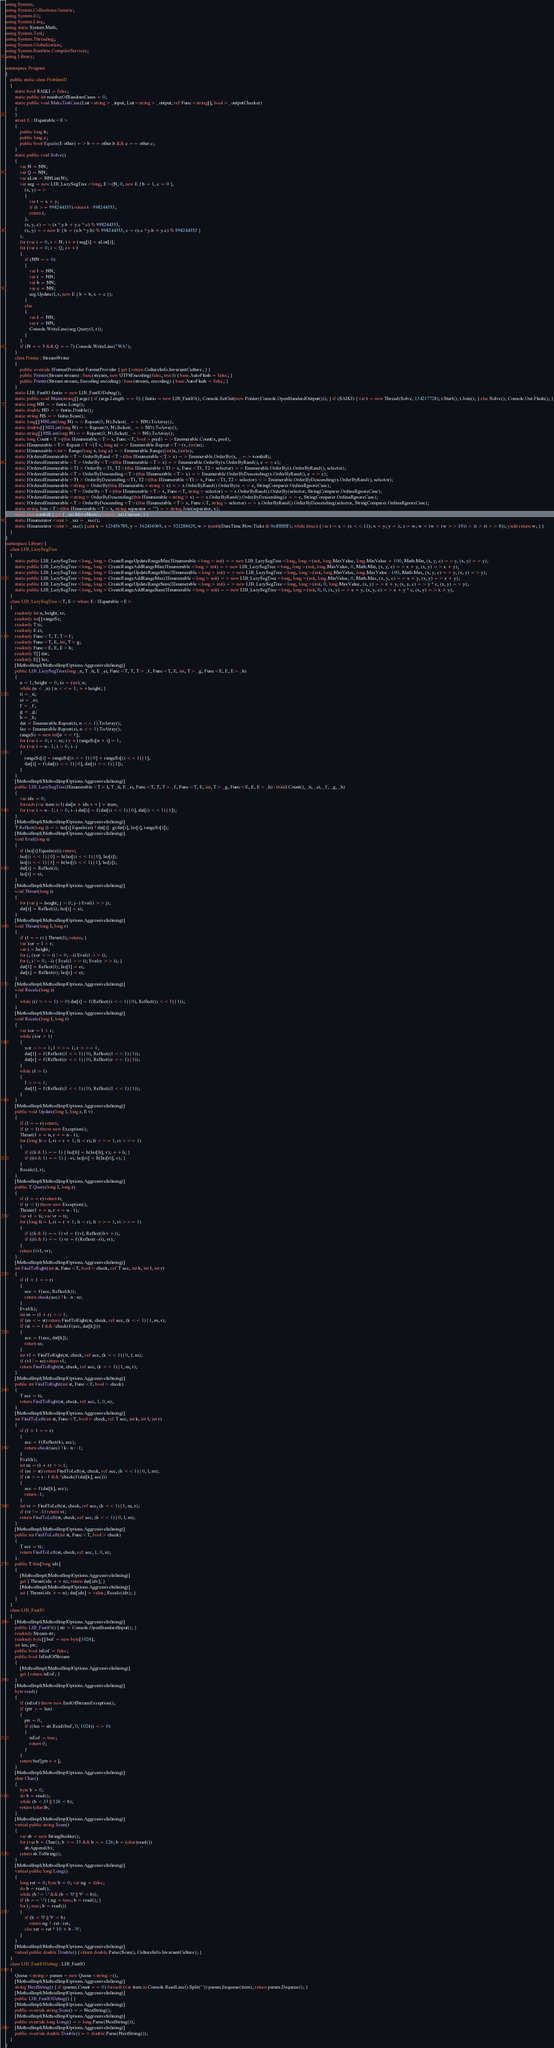Convert code to text. <code><loc_0><loc_0><loc_500><loc_500><_C#_>using System;
using System.Collections.Generic;
using System.IO;
using System.Linq;
using static System.Math;
using System.Text;
using System.Threading;
using System.Globalization;
using System.Runtime.CompilerServices;
using Library;

namespace Program
{
    public static class ProblemD
    {
        static bool SAIKI = false;
        static public int numberOfRandomCases = 0;
        static public void MakeTestCase(List<string> _input, List<string> _output, ref Func<string[], bool> _outputChecker)
        {
        }
        struct E : IEquatable<E>
        {
            public long b;
            public long c;
            public bool Equals(E other) => b == other.b && c == other.c;
        }
        static public void Solve()
        {
            var N = NN;
            var Q = NN;
            var aList = NNList(N);
            var seg = new LIB_LazySegTree<long, E>(N, 0, new E { b = 1, c = 0 },
                (x, y) =>
                {
                    var t = x + y;
                    if (t >= 998244353) return t - 998244353;
                    return t;
                },
                (x, y, c) => (x * y.b + y.c * c) % 998244353,
                (x, y) => new E { b = (x.b * y.b) % 998244353, c = (x.c * y.b + y.c) % 998244353 }
            );
            for (var i = 0; i < N; i++) seg[i] = aList[i];
            for (var i = 0; i < Q; i++)
            {
                if (NN == 0)
                {
                    var l = NN;
                    var r = NN;
                    var b = NN;
                    var c = NN;
                    seg.Update(l, r, new E { b = b, c = c });
                }
                else
                {
                    var l = NN;
                    var r = NN;
                    Console.WriteLine(seg.Query(l, r));
                }
            }
            if (N == 5 && Q == 7) Console.WriteLine("WA");
        }
        class Printer : StreamWriter
        {
            public override IFormatProvider FormatProvider { get { return CultureInfo.InvariantCulture; } }
            public Printer(Stream stream) : base(stream, new UTF8Encoding(false, true)) { base.AutoFlush = false; }
            public Printer(Stream stream, Encoding encoding) : base(stream, encoding) { base.AutoFlush = false; }
        }
        static LIB_FastIO fastio = new LIB_FastIODebug();
        static public void Main(string[] args) { if (args.Length == 0) { fastio = new LIB_FastIO(); Console.SetOut(new Printer(Console.OpenStandardOutput())); } if (SAIKI) { var t = new Thread(Solve, 134217728); t.Start(); t.Join(); } else Solve(); Console.Out.Flush(); }
        static long NN => fastio.Long();
        static double ND => fastio.Double();
        static string NS => fastio.Scan();
        static long[] NNList(long N) => Repeat(0, N).Select(_ => NN).ToArray();
        static double[] NDList(long N) => Repeat(0, N).Select(_ => ND).ToArray();
        static string[] NSList(long N) => Repeat(0, N).Select(_ => NS).ToArray();
        static long Count<T>(this IEnumerable<T> x, Func<T, bool> pred) => Enumerable.Count(x, pred);
        static IEnumerable<T> Repeat<T>(T v, long n) => Enumerable.Repeat<T>(v, (int)n);
        static IEnumerable<int> Range(long s, long c) => Enumerable.Range((int)s, (int)c);
        static IOrderedEnumerable<T> OrderByRand<T>(this IEnumerable<T> x) => Enumerable.OrderBy(x, _ => xorshift);
        static IOrderedEnumerable<T> OrderBy<T>(this IEnumerable<T> x) => Enumerable.OrderBy(x.OrderByRand(), e => e);
        static IOrderedEnumerable<T1> OrderBy<T1, T2>(this IEnumerable<T1> x, Func<T1, T2> selector) => Enumerable.OrderBy(x.OrderByRand(), selector);
        static IOrderedEnumerable<T> OrderByDescending<T>(this IEnumerable<T> x) => Enumerable.OrderByDescending(x.OrderByRand(), e => e);
        static IOrderedEnumerable<T1> OrderByDescending<T1, T2>(this IEnumerable<T1> x, Func<T1, T2> selector) => Enumerable.OrderByDescending(x.OrderByRand(), selector);
        static IOrderedEnumerable<string> OrderBy(this IEnumerable<string> x) => x.OrderByRand().OrderBy(e => e, StringComparer.OrdinalIgnoreCase);
        static IOrderedEnumerable<T> OrderBy<T>(this IEnumerable<T> x, Func<T, string> selector) => x.OrderByRand().OrderBy(selector, StringComparer.OrdinalIgnoreCase);
        static IOrderedEnumerable<string> OrderByDescending(this IEnumerable<string> x) => x.OrderByRand().OrderByDescending(e => e, StringComparer.OrdinalIgnoreCase);
        static IOrderedEnumerable<T> OrderByDescending<T>(this IEnumerable<T> x, Func<T, string> selector) => x.OrderByRand().OrderByDescending(selector, StringComparer.OrdinalIgnoreCase);
        static string Join<T>(this IEnumerable<T> x, string separator = "") => string.Join(separator, x);
        static uint xorshift { get { _xsi.MoveNext(); return _xsi.Current; } }
        static IEnumerator<uint> _xsi = _xsc();
        static IEnumerator<uint> _xsc() { uint x = 123456789, y = 362436069, z = 521288629, w = (uint)(DateTime.Now.Ticks & 0xffffffff); while (true) { var t = x ^ (x << 11); x = y; y = z; z = w; w = (w ^ (w >> 19)) ^ (t ^ (t >> 8)); yield return w; } }
    }
}
namespace Library {
    class LIB_LazySegTree
    {
        static public LIB_LazySegTree<long, long> CreateRangeUpdateRangeMin(IEnumerable<long> init) => new LIB_LazySegTree<long, long>(init, long.MaxValue, long.MinValue + 100, Math.Min, (x, y, c) => y, (x, y) => y);
        static public LIB_LazySegTree<long, long> CreateRangeAddRangeMin(IEnumerable<long> init) => new LIB_LazySegTree<long, long>(init, long.MaxValue, 0, Math.Min, (x, y, c) => x + y, (x, y) => x + y);
        static public LIB_LazySegTree<long, long> CreateRangeUpdateRangeMax(IEnumerable<long> init) => new LIB_LazySegTree<long, long>(init, long.MinValue, long.MaxValue - 100, Math.Max, (x, y, c) => y, (x, y) => y);
        static public LIB_LazySegTree<long, long> CreateRangeAddRangeMax(IEnumerable<long> init) => new LIB_LazySegTree<long, long>(init, long.MinValue, 0, Math.Max, (x, y, c) => x + y, (x, y) => x + y);
        static public LIB_LazySegTree<long, long> CreateRangeUpdateRangeSum(IEnumerable<long> init) => new LIB_LazySegTree<long, long>(init, 0, long.MaxValue, (x, y) => x + y, (x, y, c) => y * c, (x, y) => y);
        static public LIB_LazySegTree<long, long> CreateRangeAddRangeSum(IEnumerable<long> init) => new LIB_LazySegTree<long, long>(init, 0, 0, (x, y) => x + y, (x, y, c) => x + y * c, (x, y) => x + y);
    }
    class LIB_LazySegTree<T, E> where E : IEquatable<E>
    {
        readonly int n, height, sz;
        readonly int[] rangeSz;
        readonly T ti;
        readonly E ei;
        readonly Func<T, T, T> f;
        readonly Func<T, E, int, T> g;
        readonly Func<E, E, E> h;
        readonly T[] dat;
        readonly E[] laz;
        [MethodImpl(MethodImplOptions.AggressiveInlining)]
        public LIB_LazySegTree(long _n, T _ti, E _ei, Func<T, T, T> _f, Func<T, E, int, T> _g, Func<E, E, E> _h)
        {
            n = 1; height = 0; sz = (int)_n;
            while (n < _n) { n <<= 1; ++height; }
            ti = _ti;
            ei = _ei;
            f = _f;
            g = _g;
            h = _h;
            dat = Enumerable.Repeat(ti, n << 1).ToArray();
            laz = Enumerable.Repeat(ei, n << 1).ToArray();
            rangeSz = new int[n << 1];
            for (var i = 0; i < sz; i++) rangeSz[n + i] = 1;
            for (var i = n - 1; i > 0; i--)
            {
                rangeSz[i] = rangeSz[(i << 1) | 0] + rangeSz[(i << 1) | 1];
                dat[i] = f(dat[(i << 1) | 0], dat[(i << 1) | 1]);
            }
        }
        [MethodImpl(MethodImplOptions.AggressiveInlining)]
        public LIB_LazySegTree(IEnumerable<T> l, T _ti, E _ei, Func<T, T, T> _f, Func<T, E, int, T> _g, Func<E, E, E> _h) : this(l.Count(), _ti, _ei, _f, _g, _h)
        {
            var idx = 0;
            foreach (var item in l) dat[n + idx++] = item;
            for (var i = n - 1; i > 0; i--) dat[i] = f(dat[(i << 1) | 0], dat[(i << 1) | 1]);
        }
        [MethodImpl(MethodImplOptions.AggressiveInlining)]
        T Reflect(long i) => laz[i].Equals(ei) ? dat[i] : g(dat[i], laz[i], rangeSz[i]);
        [MethodImpl(MethodImplOptions.AggressiveInlining)]
        void Eval(long i)
        {
            if (laz[i].Equals(ei)) return;
            laz[(i << 1) | 0] = h(laz[(i << 1) | 0], laz[i]);
            laz[(i << 1) | 1] = h(laz[(i << 1) | 1], laz[i]);
            dat[i] = Reflect(i);
            laz[i] = ei;
        }
        [MethodImpl(MethodImplOptions.AggressiveInlining)]
        void Thrust(long i)
        {
            for (var j = height; j > 0; j--) Eval(i >> j);
            dat[i] = Reflect(i); laz[i] = ei;
        }
        [MethodImpl(MethodImplOptions.AggressiveInlining)]
        void Thrust(long l, long r)
        {
            if (l == r) { Thrust(l); return; }
            var xor = l ^ r;
            var i = height;
            for (; (xor >> i) != 0; --i) Eval(l >> i);
            for (; i != 0; --i) { Eval(l >> i); Eval(r >> i); }
            dat[l] = Reflect(l); laz[l] = ei;
            dat[r] = Reflect(r); laz[r] = ei;
        }
        [MethodImpl(MethodImplOptions.AggressiveInlining)]
        void Recalc(long i)
        {
            while ((i >>= 1) > 0) dat[i] = f(Reflect((i << 1) | 0), Reflect((i << 1) | 1));
        }
        [MethodImpl(MethodImplOptions.AggressiveInlining)]
        void Recalc(long l, long r)
        {
            var xor = l ^ r;
            while (xor > 1)
            {
                xor >>= 1; l >>= 1; r >>= 1;
                dat[l] = f(Reflect((l << 1) | 0), Reflect((l << 1) | 1));
                dat[r] = f(Reflect((r << 1) | 0), Reflect((r << 1) | 1));
            }
            while (l > 1)
            {
                l >>= 1;
                dat[l] = f(Reflect((l << 1) | 0), Reflect((l << 1) | 1));
            }
        }
        [MethodImpl(MethodImplOptions.AggressiveInlining)]
        public void Update(long l, long r, E v)
        {
            if (l == r) return;
            if (r < l) throw new Exception();
            Thrust(l += n, r += n - 1);
            for (long li = l, ri = r + 1; li < ri; li >>= 1, ri >>= 1)
            {
                if ((li & 1) == 1) { laz[li] = h(laz[li], v); ++li; }
                if ((ri & 1) == 1) { --ri; laz[ri] = h(laz[ri], v); }
            }
            Recalc(l, r);
        }
        [MethodImpl(MethodImplOptions.AggressiveInlining)]
        public T Query(long l, long r)
        {
            if (l == r) return ti;
            if (r < l) throw new Exception();
            Thrust(l += n, r += n - 1);
            var vl = ti; var vr = ti;
            for (long li = l, ri = r + 1; li < ri; li >>= 1, ri >>= 1)
            {
                if ((li & 1) == 1) vl = f(vl, Reflect(li++));
                if ((ri & 1) == 1) vr = f(Reflect(--ri), vr);
            }
            return f(vl, vr);
        }
        [MethodImpl(MethodImplOptions.AggressiveInlining)]
        int FindToRight(int st, Func<T, bool> check, ref T acc, int k, int l, int r)
        {
            if (l + 1 == r)
            {
                acc = f(acc, Reflect(k));
                return check(acc) ? k - n : sz;
            }
            Eval(k);
            int m = (l + r) >> 1;
            if (m <= st) return FindToRight(st, check, ref acc, (k << 1) | 1, m, r);
            if (st <= l && !check(f(acc, dat[k])))
            {
                acc = f(acc, dat[k]);
                return sz;
            }
            int vl = FindToRight(st, check, ref acc, (k << 1) | 0, l, m);
            if (vl != sz) return vl;
            return FindToRight(st, check, ref acc, (k << 1) | 1, m, r);
        }
        [MethodImpl(MethodImplOptions.AggressiveInlining)]
        public int FindToRight(int st, Func<T, bool> check)
        {
            T acc = ti;
            return FindToRight(st, check, ref acc, 1, 0, n);
        }
        [MethodImpl(MethodImplOptions.AggressiveInlining)]
        int FindToLeft(int st, Func<T, bool> check, ref T acc, int k, int l, int r)
        {
            if (l + 1 == r)
            {
                acc = f(Reflect(k), acc);
                return check(acc) ? k - n : -1;
            }
            Eval(k);
            int m = (l + r) >> 1;
            if (m > st) return FindToLeft(st, check, ref acc, (k << 1) | 0, l, m);
            if (st >= r - 1 && !check(f(dat[k], acc)))
            {
                acc = f(dat[k], acc);
                return -1;
            }
            int vr = FindToLeft(st, check, ref acc, (k << 1) | 1, m, r);
            if (vr != -1) return vr;
            return FindToLeft(st, check, ref acc, (k << 1) | 0, l, m);
        }
        [MethodImpl(MethodImplOptions.AggressiveInlining)]
        public int FindToLeft(int st, Func<T, bool> check)
        {
            T acc = ti;
            return FindToLeft(st, check, ref acc, 1, 0, n);
        }
        public T this[long idx]
        {
            [MethodImpl(MethodImplOptions.AggressiveInlining)]
            get { Thrust(idx += n); return dat[idx]; }
            [MethodImpl(MethodImplOptions.AggressiveInlining)]
            set { Thrust(idx += n); dat[idx] = value; Recalc(idx); }
        }
    }
    class LIB_FastIO
    {
        [MethodImpl(MethodImplOptions.AggressiveInlining)]
        public LIB_FastIO() { str = Console.OpenStandardInput(); }
        readonly Stream str;
        readonly byte[] buf = new byte[1024];
        int len, ptr;
        public bool isEof = false;
        public bool IsEndOfStream
        {
            [MethodImpl(MethodImplOptions.AggressiveInlining)]
            get { return isEof; }
        }
        [MethodImpl(MethodImplOptions.AggressiveInlining)]
        byte read()
        {
            if (isEof) throw new EndOfStreamException();
            if (ptr >= len)
            {
                ptr = 0;
                if ((len = str.Read(buf, 0, 1024)) <= 0)
                {
                    isEof = true;
                    return 0;
                }
            }
            return buf[ptr++];
        }
        [MethodImpl(MethodImplOptions.AggressiveInlining)]
        char Char()
        {
            byte b = 0;
            do b = read();
            while (b < 33 || 126 < b);
            return (char)b;
        }
        [MethodImpl(MethodImplOptions.AggressiveInlining)]
        virtual public string Scan()
        {
            var sb = new StringBuilder();
            for (var b = Char(); b >= 33 && b <= 126; b = (char)read())
                sb.Append(b);
            return sb.ToString();
        }
        [MethodImpl(MethodImplOptions.AggressiveInlining)]
        virtual public long Long()
        {
            long ret = 0; byte b = 0; var ng = false;
            do b = read();
            while (b != '-' && (b < '0' || '9' < b));
            if (b == '-') { ng = true; b = read(); }
            for (; true; b = read())
            {
                if (b < '0' || '9' < b)
                    return ng ? -ret : ret;
                else ret = ret * 10 + b - '0';
            }
        }
        [MethodImpl(MethodImplOptions.AggressiveInlining)]
        virtual public double Double() { return double.Parse(Scan(), CultureInfo.InvariantCulture); }
    }
    class LIB_FastIODebug : LIB_FastIO
    {
        Queue<string> param = new Queue<string>();
        [MethodImpl(MethodImplOptions.AggressiveInlining)]
        string NextString() { if (param.Count == 0) foreach (var item in Console.ReadLine().Split(' ')) param.Enqueue(item); return param.Dequeue(); }
        [MethodImpl(MethodImplOptions.AggressiveInlining)]
        public LIB_FastIODebug() { }
        [MethodImpl(MethodImplOptions.AggressiveInlining)]
        public override string Scan() => NextString();
        [MethodImpl(MethodImplOptions.AggressiveInlining)]
        public override long Long() => long.Parse(NextString());
        [MethodImpl(MethodImplOptions.AggressiveInlining)]
        public override double Double() => double.Parse(NextString());
    }
}
</code> 